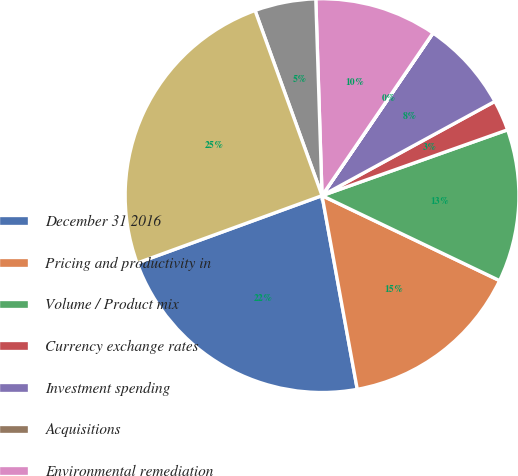<chart> <loc_0><loc_0><loc_500><loc_500><pie_chart><fcel>December 31 2016<fcel>Pricing and productivity in<fcel>Volume / Product mix<fcel>Currency exchange rates<fcel>Investment spending<fcel>Acquisitions<fcel>Environmental remediation<fcel>Restructuring / acquisition<fcel>December 31 2017<nl><fcel>22.3%<fcel>15.03%<fcel>12.53%<fcel>2.52%<fcel>7.52%<fcel>0.01%<fcel>10.03%<fcel>5.02%<fcel>25.04%<nl></chart> 